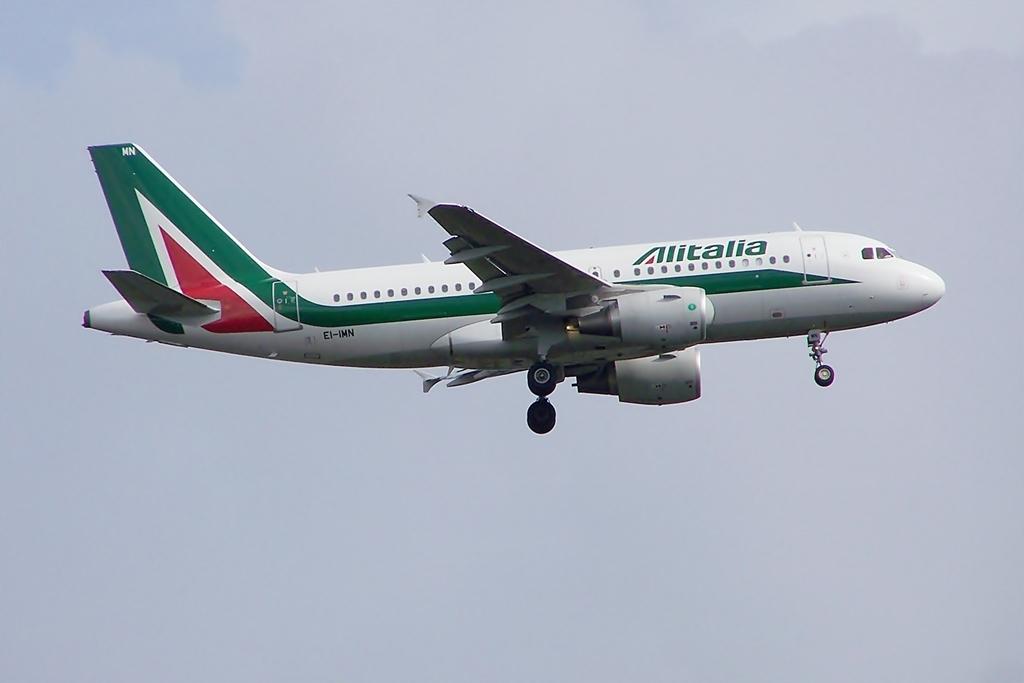Which airline does this plane belong to?
Give a very brief answer. Alitalia. What is the planes id number?
Keep it short and to the point. Ei-imn. 